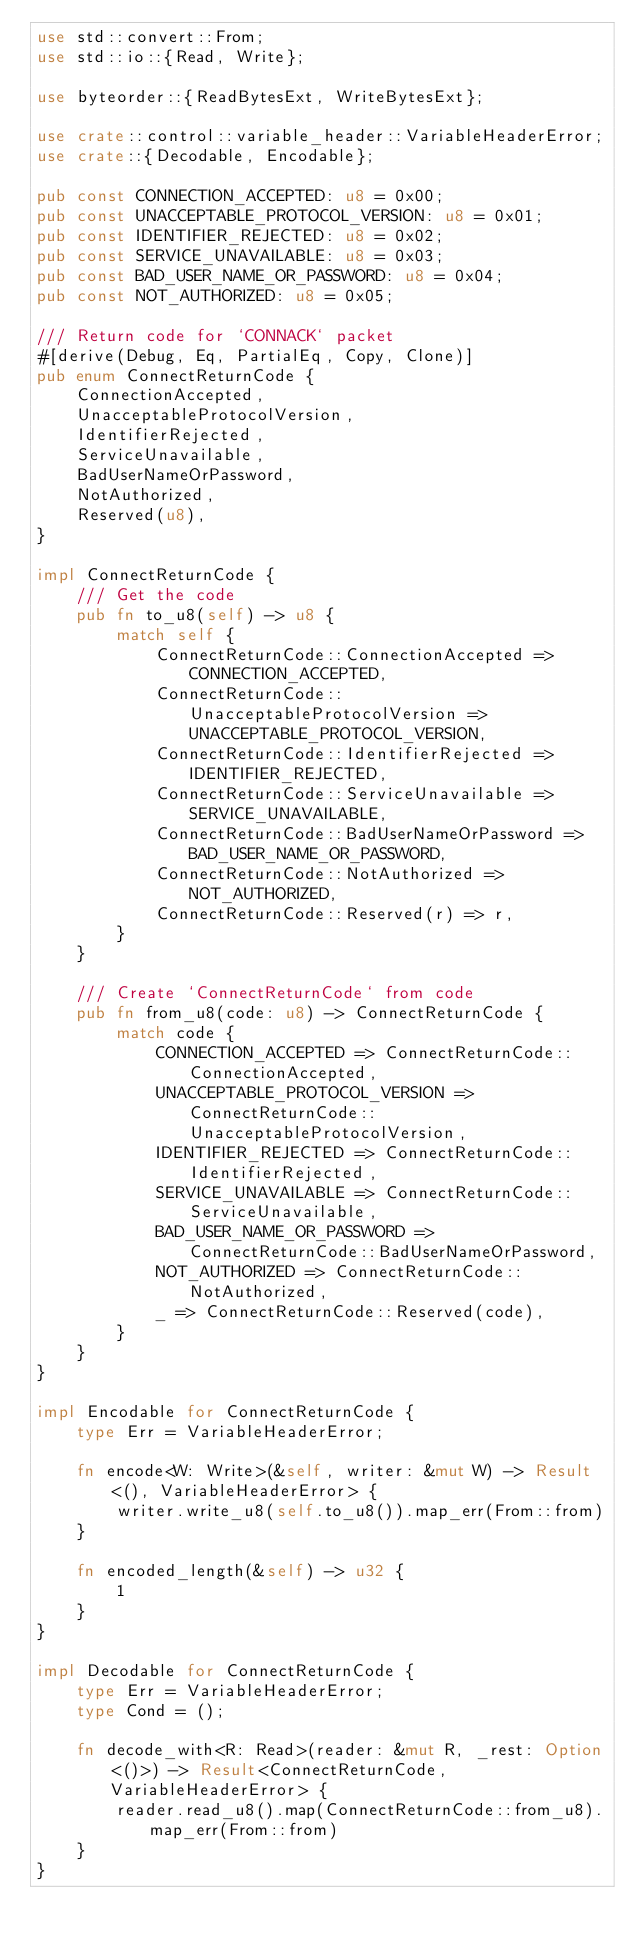<code> <loc_0><loc_0><loc_500><loc_500><_Rust_>use std::convert::From;
use std::io::{Read, Write};

use byteorder::{ReadBytesExt, WriteBytesExt};

use crate::control::variable_header::VariableHeaderError;
use crate::{Decodable, Encodable};

pub const CONNECTION_ACCEPTED: u8 = 0x00;
pub const UNACCEPTABLE_PROTOCOL_VERSION: u8 = 0x01;
pub const IDENTIFIER_REJECTED: u8 = 0x02;
pub const SERVICE_UNAVAILABLE: u8 = 0x03;
pub const BAD_USER_NAME_OR_PASSWORD: u8 = 0x04;
pub const NOT_AUTHORIZED: u8 = 0x05;

/// Return code for `CONNACK` packet
#[derive(Debug, Eq, PartialEq, Copy, Clone)]
pub enum ConnectReturnCode {
    ConnectionAccepted,
    UnacceptableProtocolVersion,
    IdentifierRejected,
    ServiceUnavailable,
    BadUserNameOrPassword,
    NotAuthorized,
    Reserved(u8),
}

impl ConnectReturnCode {
    /// Get the code
    pub fn to_u8(self) -> u8 {
        match self {
            ConnectReturnCode::ConnectionAccepted => CONNECTION_ACCEPTED,
            ConnectReturnCode::UnacceptableProtocolVersion => UNACCEPTABLE_PROTOCOL_VERSION,
            ConnectReturnCode::IdentifierRejected => IDENTIFIER_REJECTED,
            ConnectReturnCode::ServiceUnavailable => SERVICE_UNAVAILABLE,
            ConnectReturnCode::BadUserNameOrPassword => BAD_USER_NAME_OR_PASSWORD,
            ConnectReturnCode::NotAuthorized => NOT_AUTHORIZED,
            ConnectReturnCode::Reserved(r) => r,
        }
    }

    /// Create `ConnectReturnCode` from code
    pub fn from_u8(code: u8) -> ConnectReturnCode {
        match code {
            CONNECTION_ACCEPTED => ConnectReturnCode::ConnectionAccepted,
            UNACCEPTABLE_PROTOCOL_VERSION => ConnectReturnCode::UnacceptableProtocolVersion,
            IDENTIFIER_REJECTED => ConnectReturnCode::IdentifierRejected,
            SERVICE_UNAVAILABLE => ConnectReturnCode::ServiceUnavailable,
            BAD_USER_NAME_OR_PASSWORD => ConnectReturnCode::BadUserNameOrPassword,
            NOT_AUTHORIZED => ConnectReturnCode::NotAuthorized,
            _ => ConnectReturnCode::Reserved(code),
        }
    }
}

impl Encodable for ConnectReturnCode {
    type Err = VariableHeaderError;

    fn encode<W: Write>(&self, writer: &mut W) -> Result<(), VariableHeaderError> {
        writer.write_u8(self.to_u8()).map_err(From::from)
    }

    fn encoded_length(&self) -> u32 {
        1
    }
}

impl Decodable for ConnectReturnCode {
    type Err = VariableHeaderError;
    type Cond = ();

    fn decode_with<R: Read>(reader: &mut R, _rest: Option<()>) -> Result<ConnectReturnCode, VariableHeaderError> {
        reader.read_u8().map(ConnectReturnCode::from_u8).map_err(From::from)
    }
}
</code> 